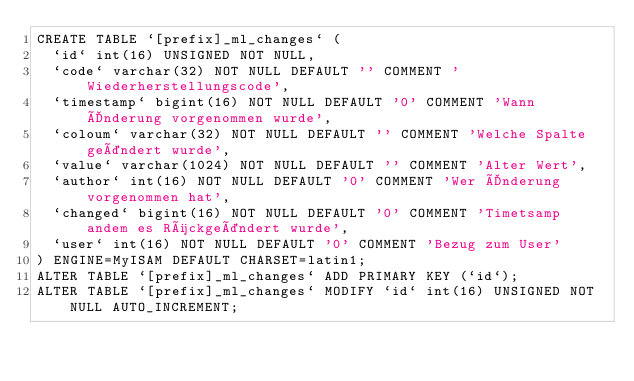Convert code to text. <code><loc_0><loc_0><loc_500><loc_500><_SQL_>CREATE TABLE `[prefix]_ml_changes` (
  `id` int(16) UNSIGNED NOT NULL,
  `code` varchar(32) NOT NULL DEFAULT '' COMMENT 'Wiederherstellungscode',
  `timestamp` bigint(16) NOT NULL DEFAULT '0' COMMENT 'Wann Änderung vorgenommen wurde',
  `coloum` varchar(32) NOT NULL DEFAULT '' COMMENT 'Welche Spalte geändert wurde',
  `value` varchar(1024) NOT NULL DEFAULT '' COMMENT 'Alter Wert',
  `author` int(16) NOT NULL DEFAULT '0' COMMENT 'Wer Änderung vorgenommen hat',
  `changed` bigint(16) NOT NULL DEFAULT '0' COMMENT 'Timetsamp andem es Rückgeändert wurde',
  `user` int(16) NOT NULL DEFAULT '0' COMMENT 'Bezug zum User'
) ENGINE=MyISAM DEFAULT CHARSET=latin1;
ALTER TABLE `[prefix]_ml_changes` ADD PRIMARY KEY (`id`);
ALTER TABLE `[prefix]_ml_changes` MODIFY `id` int(16) UNSIGNED NOT NULL AUTO_INCREMENT;</code> 